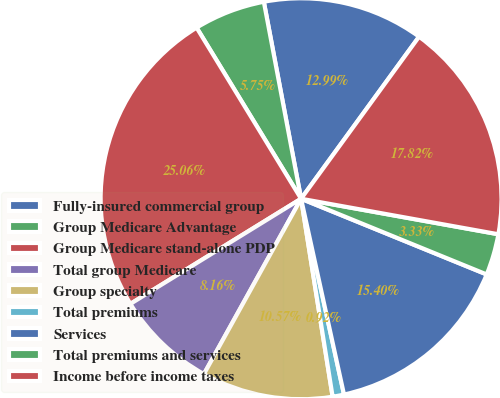<chart> <loc_0><loc_0><loc_500><loc_500><pie_chart><fcel>Fully-insured commercial group<fcel>Group Medicare Advantage<fcel>Group Medicare stand-alone PDP<fcel>Total group Medicare<fcel>Group specialty<fcel>Total premiums<fcel>Services<fcel>Total premiums and services<fcel>Income before income taxes<nl><fcel>12.99%<fcel>5.75%<fcel>25.06%<fcel>8.16%<fcel>10.57%<fcel>0.92%<fcel>15.4%<fcel>3.33%<fcel>17.82%<nl></chart> 